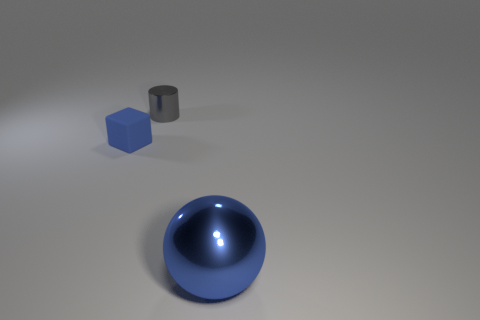There is a blue object that is on the right side of the gray object; is it the same shape as the tiny gray object?
Your response must be concise. No. What shape is the blue thing that is on the left side of the object behind the matte block?
Make the answer very short. Cube. Is there any other thing that is the same shape as the tiny gray object?
Keep it short and to the point. No. There is a tiny rubber thing; is its color the same as the shiny object behind the shiny sphere?
Make the answer very short. No. There is a object that is to the right of the tiny blue object and behind the large blue shiny object; what shape is it?
Your response must be concise. Cylinder. Are there fewer small gray shiny cylinders than purple shiny cylinders?
Ensure brevity in your answer.  No. Are there any tiny purple metallic objects?
Provide a succinct answer. No. How many other things are there of the same size as the blue cube?
Provide a short and direct response. 1. Are the blue block and the object that is to the right of the tiny gray cylinder made of the same material?
Your response must be concise. No. Are there an equal number of tiny blocks that are behind the rubber cube and gray cylinders to the right of the small gray cylinder?
Your answer should be compact. Yes. 